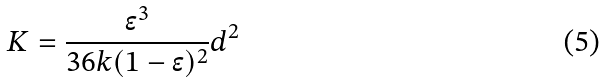Convert formula to latex. <formula><loc_0><loc_0><loc_500><loc_500>K = \frac { \epsilon ^ { 3 } } { 3 6 k ( 1 - \epsilon ) ^ { 2 } } d ^ { 2 }</formula> 